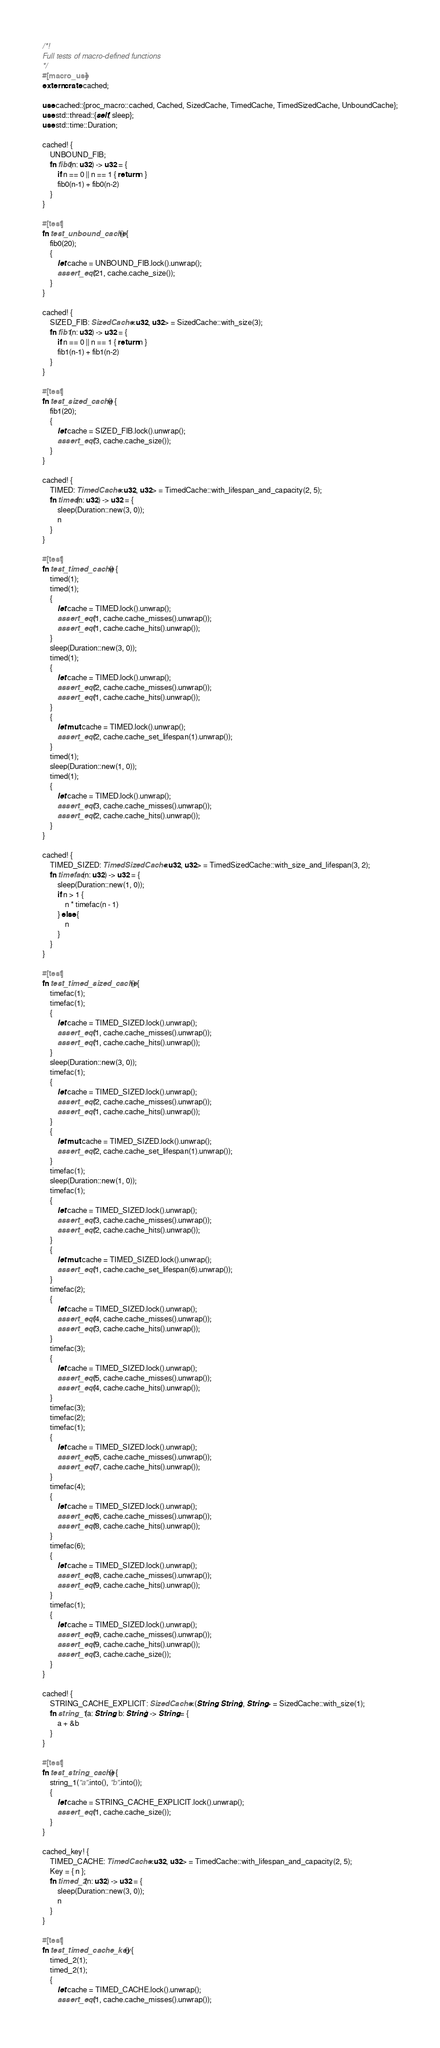<code> <loc_0><loc_0><loc_500><loc_500><_Rust_>/*!
Full tests of macro-defined functions
*/
#[macro_use]
extern crate cached;

use cached::{proc_macro::cached, Cached, SizedCache, TimedCache, TimedSizedCache, UnboundCache};
use std::thread::{self, sleep};
use std::time::Duration;

cached! {
    UNBOUND_FIB;
    fn fib0(n: u32) -> u32 = {
        if n == 0 || n == 1 { return n }
        fib0(n-1) + fib0(n-2)
    }
}

#[test]
fn test_unbound_cache() {
    fib0(20);
    {
        let cache = UNBOUND_FIB.lock().unwrap();
        assert_eq!(21, cache.cache_size());
    }
}

cached! {
    SIZED_FIB: SizedCache<u32, u32> = SizedCache::with_size(3);
    fn fib1(n: u32) -> u32 = {
        if n == 0 || n == 1 { return n }
        fib1(n-1) + fib1(n-2)
    }
}

#[test]
fn test_sized_cache() {
    fib1(20);
    {
        let cache = SIZED_FIB.lock().unwrap();
        assert_eq!(3, cache.cache_size());
    }
}

cached! {
    TIMED: TimedCache<u32, u32> = TimedCache::with_lifespan_and_capacity(2, 5);
    fn timed(n: u32) -> u32 = {
        sleep(Duration::new(3, 0));
        n
    }
}

#[test]
fn test_timed_cache() {
    timed(1);
    timed(1);
    {
        let cache = TIMED.lock().unwrap();
        assert_eq!(1, cache.cache_misses().unwrap());
        assert_eq!(1, cache.cache_hits().unwrap());
    }
    sleep(Duration::new(3, 0));
    timed(1);
    {
        let cache = TIMED.lock().unwrap();
        assert_eq!(2, cache.cache_misses().unwrap());
        assert_eq!(1, cache.cache_hits().unwrap());
    }
    {
        let mut cache = TIMED.lock().unwrap();
        assert_eq!(2, cache.cache_set_lifespan(1).unwrap());
    }
    timed(1);
    sleep(Duration::new(1, 0));
    timed(1);
    {
        let cache = TIMED.lock().unwrap();
        assert_eq!(3, cache.cache_misses().unwrap());
        assert_eq!(2, cache.cache_hits().unwrap());
    }
}

cached! {
    TIMED_SIZED: TimedSizedCache<u32, u32> = TimedSizedCache::with_size_and_lifespan(3, 2);
    fn timefac(n: u32) -> u32 = {
        sleep(Duration::new(1, 0));
        if n > 1 {
            n * timefac(n - 1)
        } else {
            n
        }
    }
}

#[test]
fn test_timed_sized_cache() {
    timefac(1);
    timefac(1);
    {
        let cache = TIMED_SIZED.lock().unwrap();
        assert_eq!(1, cache.cache_misses().unwrap());
        assert_eq!(1, cache.cache_hits().unwrap());
    }
    sleep(Duration::new(3, 0));
    timefac(1);
    {
        let cache = TIMED_SIZED.lock().unwrap();
        assert_eq!(2, cache.cache_misses().unwrap());
        assert_eq!(1, cache.cache_hits().unwrap());
    }
    {
        let mut cache = TIMED_SIZED.lock().unwrap();
        assert_eq!(2, cache.cache_set_lifespan(1).unwrap());
    }
    timefac(1);
    sleep(Duration::new(1, 0));
    timefac(1);
    {
        let cache = TIMED_SIZED.lock().unwrap();
        assert_eq!(3, cache.cache_misses().unwrap());
        assert_eq!(2, cache.cache_hits().unwrap());
    }
    {
        let mut cache = TIMED_SIZED.lock().unwrap();
        assert_eq!(1, cache.cache_set_lifespan(6).unwrap());
    }
    timefac(2);
    {
        let cache = TIMED_SIZED.lock().unwrap();
        assert_eq!(4, cache.cache_misses().unwrap());
        assert_eq!(3, cache.cache_hits().unwrap());
    }
    timefac(3);
    {
        let cache = TIMED_SIZED.lock().unwrap();
        assert_eq!(5, cache.cache_misses().unwrap());
        assert_eq!(4, cache.cache_hits().unwrap());
    }
    timefac(3);
    timefac(2);
    timefac(1);
    {
        let cache = TIMED_SIZED.lock().unwrap();
        assert_eq!(5, cache.cache_misses().unwrap());
        assert_eq!(7, cache.cache_hits().unwrap());
    }
    timefac(4);
    {
        let cache = TIMED_SIZED.lock().unwrap();
        assert_eq!(6, cache.cache_misses().unwrap());
        assert_eq!(8, cache.cache_hits().unwrap());
    }
    timefac(6);
    {
        let cache = TIMED_SIZED.lock().unwrap();
        assert_eq!(8, cache.cache_misses().unwrap());
        assert_eq!(9, cache.cache_hits().unwrap());
    }
    timefac(1);
    {
        let cache = TIMED_SIZED.lock().unwrap();
        assert_eq!(9, cache.cache_misses().unwrap());
        assert_eq!(9, cache.cache_hits().unwrap());
        assert_eq!(3, cache.cache_size());
    }
}

cached! {
    STRING_CACHE_EXPLICIT: SizedCache<(String, String), String> = SizedCache::with_size(1);
    fn string_1(a: String, b: String) -> String = {
        a + &b
    }
}

#[test]
fn test_string_cache() {
    string_1("a".into(), "b".into());
    {
        let cache = STRING_CACHE_EXPLICIT.lock().unwrap();
        assert_eq!(1, cache.cache_size());
    }
}

cached_key! {
    TIMED_CACHE: TimedCache<u32, u32> = TimedCache::with_lifespan_and_capacity(2, 5);
    Key = { n };
    fn timed_2(n: u32) -> u32 = {
        sleep(Duration::new(3, 0));
        n
    }
}

#[test]
fn test_timed_cache_key() {
    timed_2(1);
    timed_2(1);
    {
        let cache = TIMED_CACHE.lock().unwrap();
        assert_eq!(1, cache.cache_misses().unwrap());</code> 